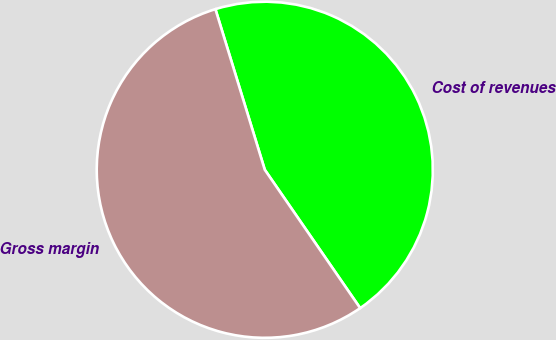Convert chart. <chart><loc_0><loc_0><loc_500><loc_500><pie_chart><fcel>Cost of revenues<fcel>Gross margin<nl><fcel>45.14%<fcel>54.86%<nl></chart> 